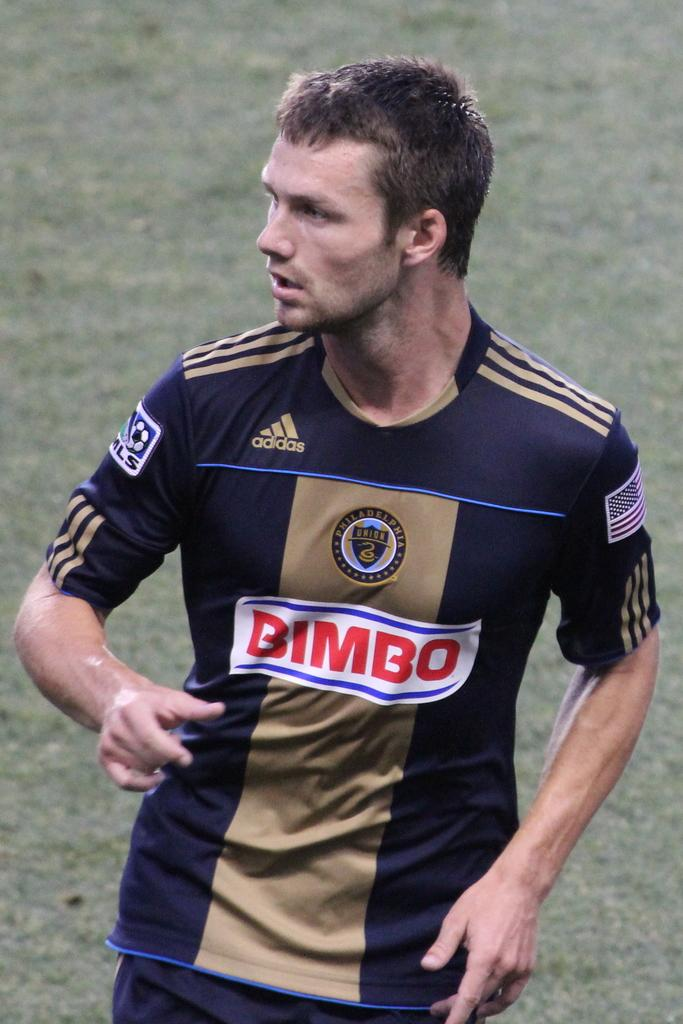<image>
Offer a succinct explanation of the picture presented. A professional soccer play for the Philadelphia Union looks to his right. 